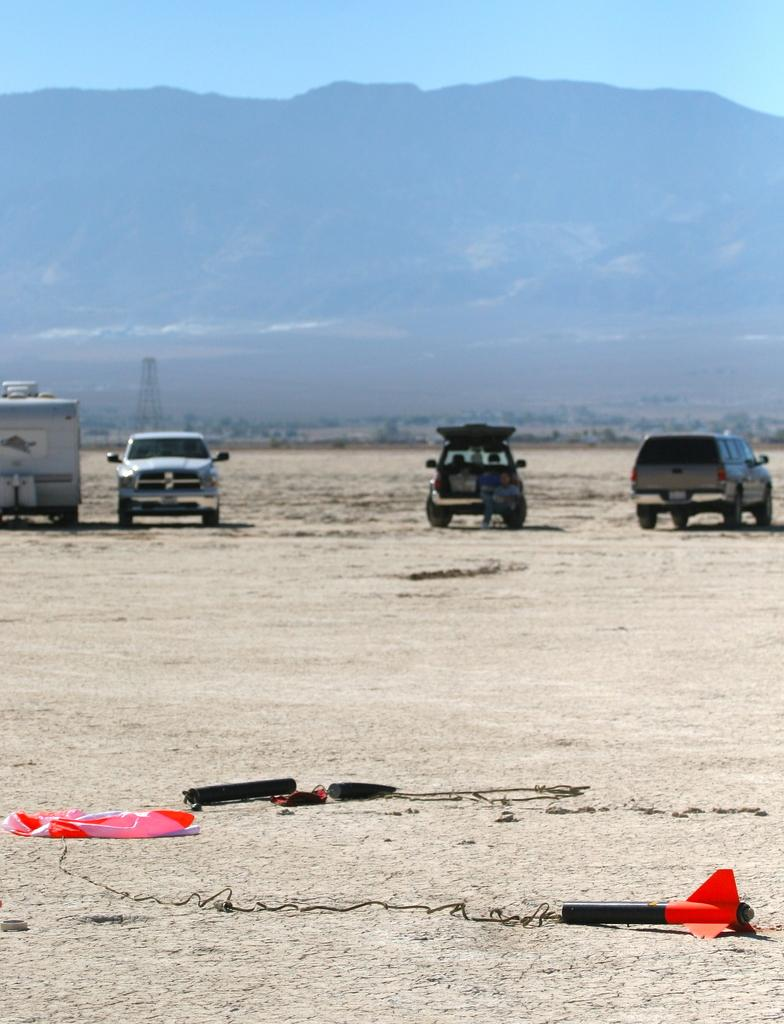What type of natural formation can be seen in the background of the image? There are mountains in the background of the image. What type of terrain is at the bottom of the image? There is sand at the bottom of the image. What is present on the sand in the image? There are objects on the sand. What type of transportation is visible in the image? There are vehicles in the image. What is visible at the top of the image? The sky is visible at the top of the image. What type of cookware is being used by the cook in the image? There is no cook or cookware present in the image. What type of insurance policy is being discussed by the people in the image? There are no people discussing insurance in the image. 